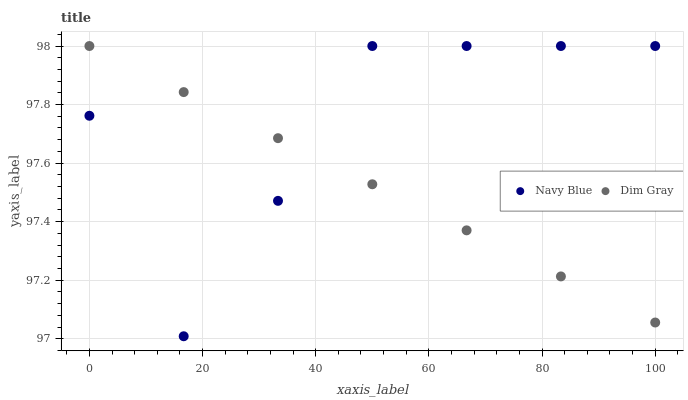Does Dim Gray have the minimum area under the curve?
Answer yes or no. Yes. Does Navy Blue have the maximum area under the curve?
Answer yes or no. Yes. Does Dim Gray have the maximum area under the curve?
Answer yes or no. No. Is Dim Gray the smoothest?
Answer yes or no. Yes. Is Navy Blue the roughest?
Answer yes or no. Yes. Is Dim Gray the roughest?
Answer yes or no. No. Does Navy Blue have the lowest value?
Answer yes or no. Yes. Does Dim Gray have the lowest value?
Answer yes or no. No. Does Dim Gray have the highest value?
Answer yes or no. Yes. Does Navy Blue intersect Dim Gray?
Answer yes or no. Yes. Is Navy Blue less than Dim Gray?
Answer yes or no. No. Is Navy Blue greater than Dim Gray?
Answer yes or no. No. 